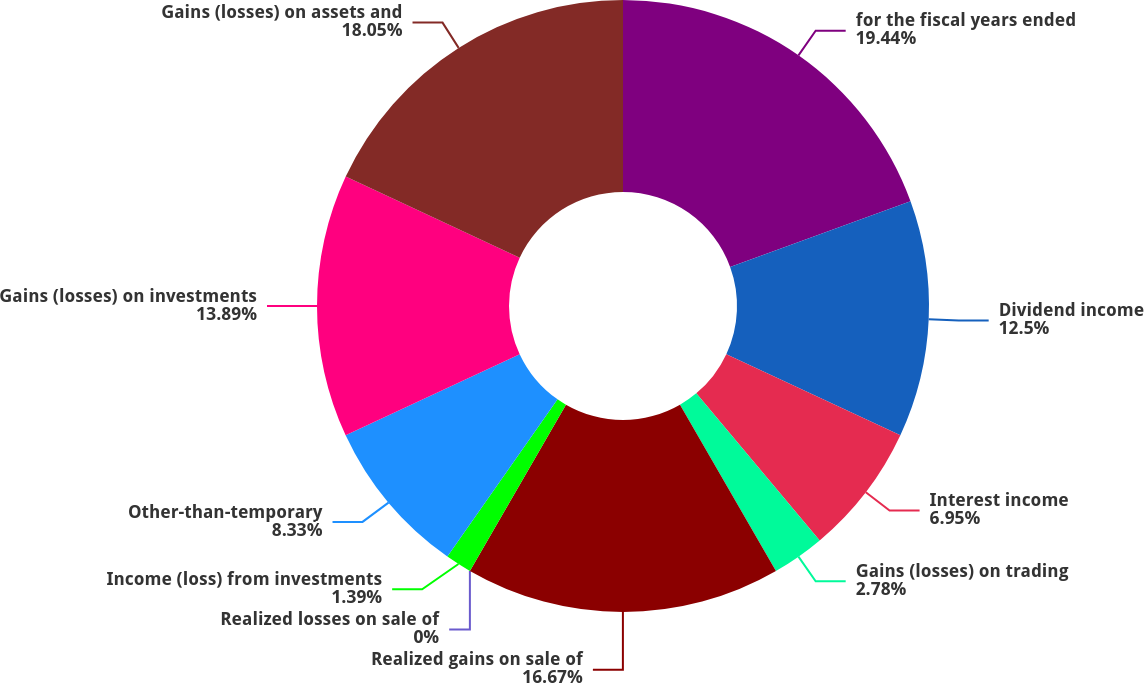Convert chart. <chart><loc_0><loc_0><loc_500><loc_500><pie_chart><fcel>for the fiscal years ended<fcel>Dividend income<fcel>Interest income<fcel>Gains (losses) on trading<fcel>Realized gains on sale of<fcel>Realized losses on sale of<fcel>Income (loss) from investments<fcel>Other-than-temporary<fcel>Gains (losses) on investments<fcel>Gains (losses) on assets and<nl><fcel>19.44%<fcel>12.5%<fcel>6.95%<fcel>2.78%<fcel>16.67%<fcel>0.0%<fcel>1.39%<fcel>8.33%<fcel>13.89%<fcel>18.05%<nl></chart> 